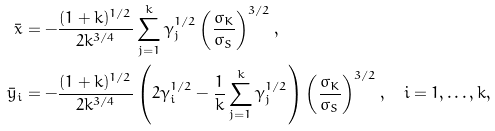Convert formula to latex. <formula><loc_0><loc_0><loc_500><loc_500>\bar { x } & = - \frac { ( 1 + k ) ^ { 1 / 2 } } { 2 k ^ { 3 / 4 } } \sum _ { j = 1 } ^ { k } \gamma _ { j } ^ { 1 / 2 } \left ( \frac { \sigma _ { K } } { \sigma _ { S } } \right ) ^ { 3 / 2 } , \\ \bar { y } _ { i } & = - \frac { ( 1 + k ) ^ { 1 / 2 } } { 2 k ^ { 3 / 4 } } \left ( 2 \gamma _ { i } ^ { 1 / 2 } - \frac { 1 } { k } \sum _ { j = 1 } ^ { k } \gamma _ { j } ^ { 1 / 2 } \right ) \left ( \frac { \sigma _ { K } } { \sigma _ { S } } \right ) ^ { 3 / 2 } , \quad i = 1 , \dots , k ,</formula> 